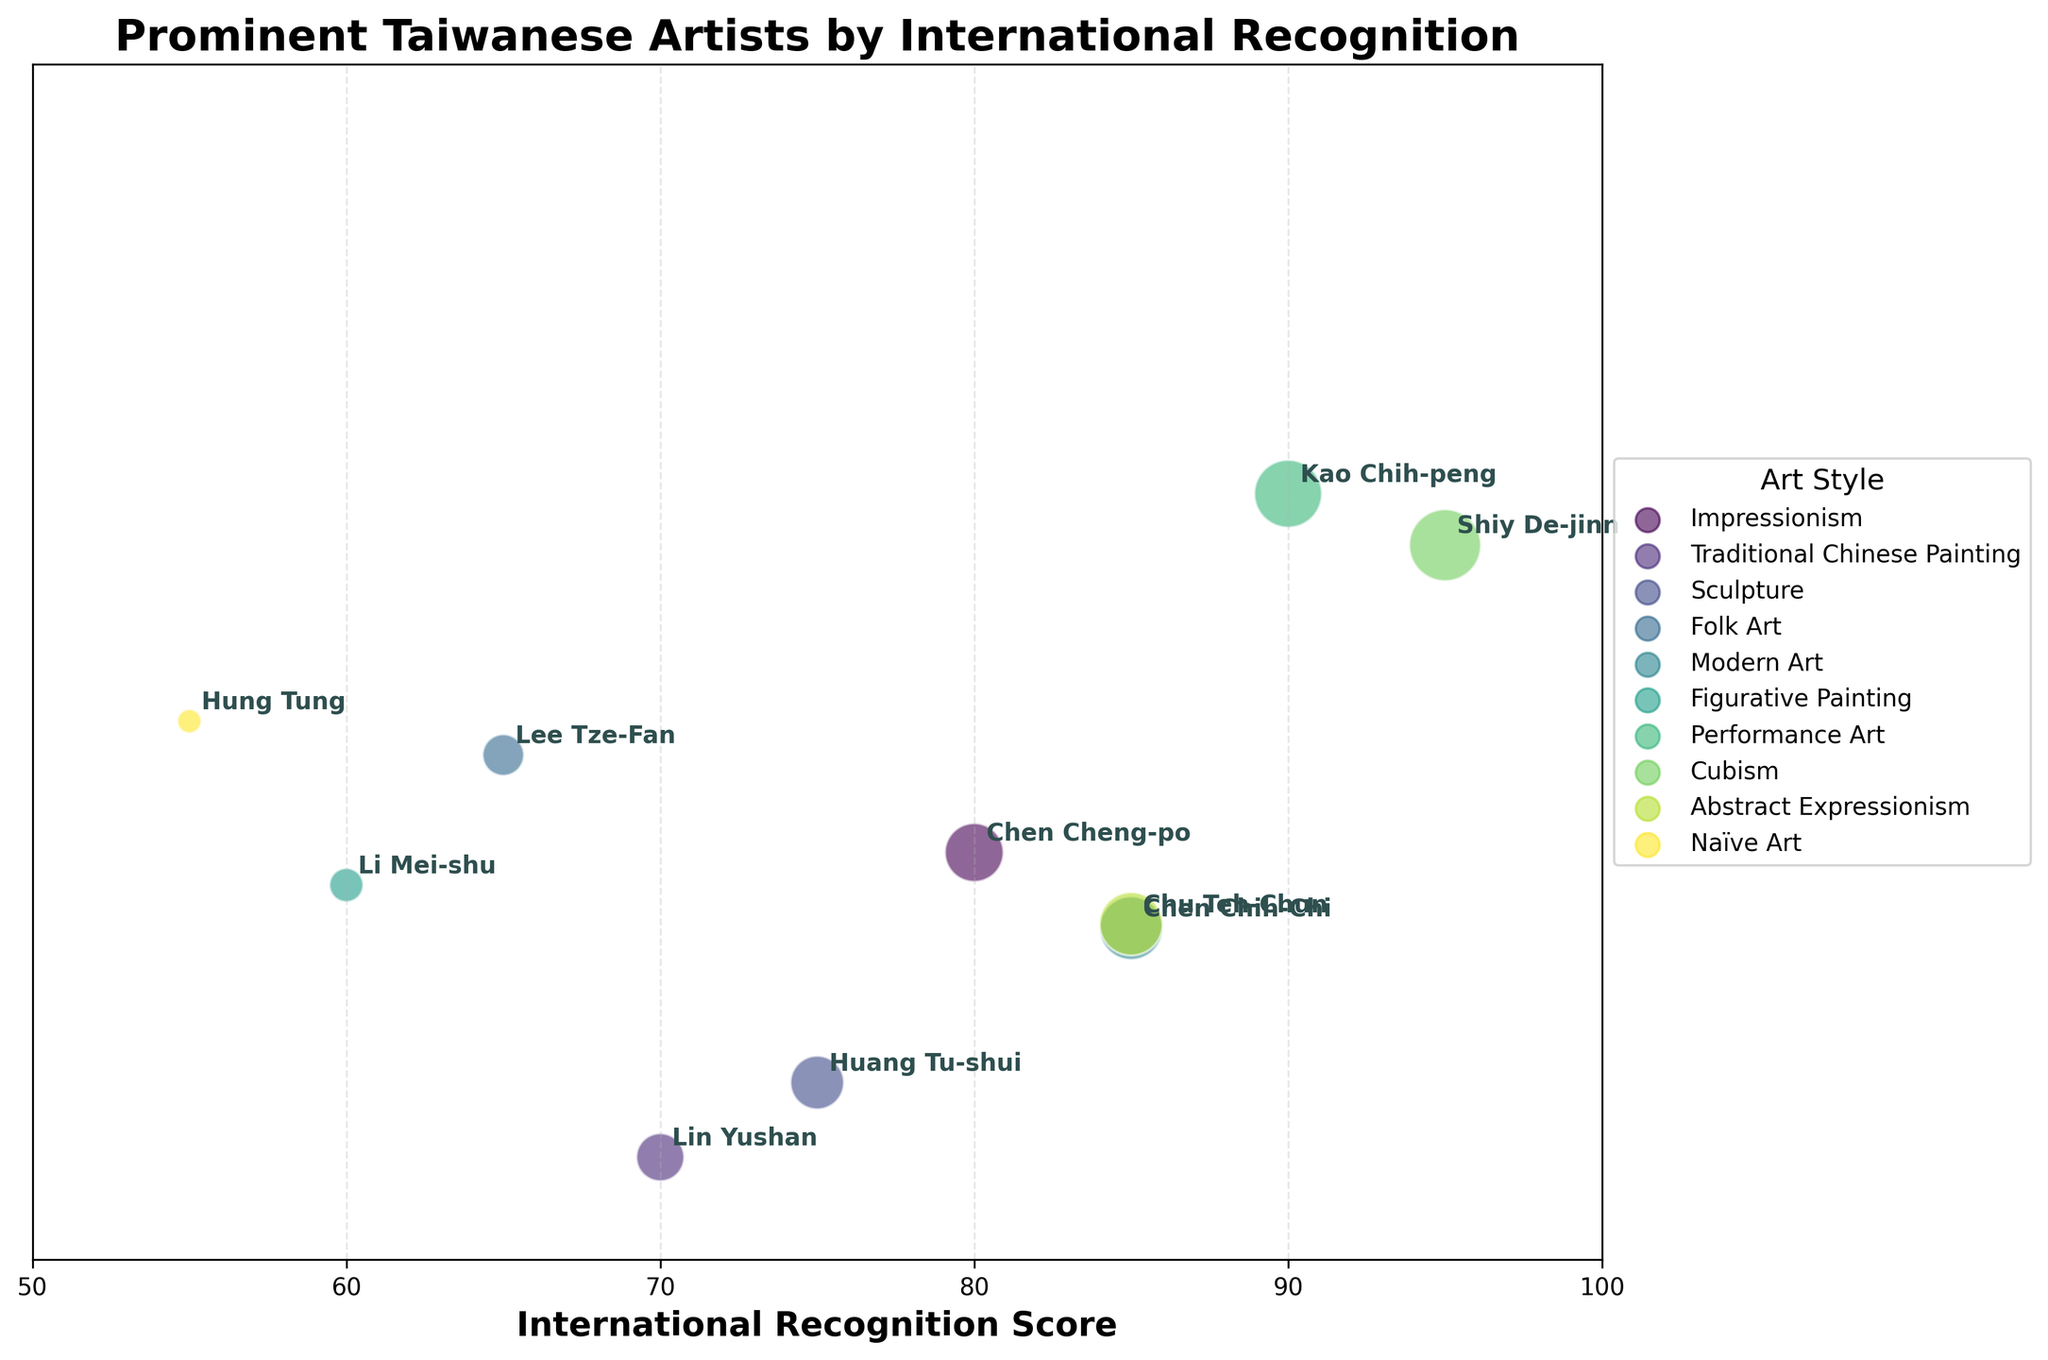What is the title of the figure? The title is displayed at the top of the figure, indicating the subject of the chart.
Answer: Prominent Taiwanese Artists by International Recognition How many artists' data points are shown in the figure? Each artist is represented by a bubble in the chart. We can count the number of bubbles to determine the number of artists.
Answer: 10 Which artist has the highest International Recognition Score? We need to identify the bubble that is farthest to the right on the x-axis, as it represents the highest International Recognition Score.
Answer: Shiy De-jinn What is the International Recognition Score of Lin Yushan? We locate Lin Yushan's bubble and read its corresponding x-axis value.
Answer: 70 Who are the two artists tied with an International Recognition Score of 85? We look for two bubbles aligned vertically at the x-axis value of 85 and read the associated artist names.
Answer: Chen Chih-Chi and Chu Teh-Chun Which art style is associated with the largest bubble? The largest bubble represents the highest International Recognition Score. We find the corresponding bubble and read the associated art style.
Answer: Cubism How many different art styles are represented in the figure? We count the unique art styles from the legend on the right side of the figure.
Answer: 9 Which artist has the smallest bubble, indicating the lowest recognition score? We identify the smallest bubble in the chart and read the associated artist name.
Answer: Hung Tung Which artist has a recognition score closest to the median value of the data set? To find the median International Recognition Score, we sort the scores and find the middle value, then identify the artist with that score.
Answer: Huang Tu-shui (Median score of around 75) Compare the recognition scores of artists from Taipei and Kaohsiung. Who has the higher score, and what's the difference? We find the scores for artists from Taipei (Chen Cheng-po) and Kaohsiung (Kao Chih-peng), then calculate the difference.
Answer: Kao Chih-peng has a higher score. Difference: 10 